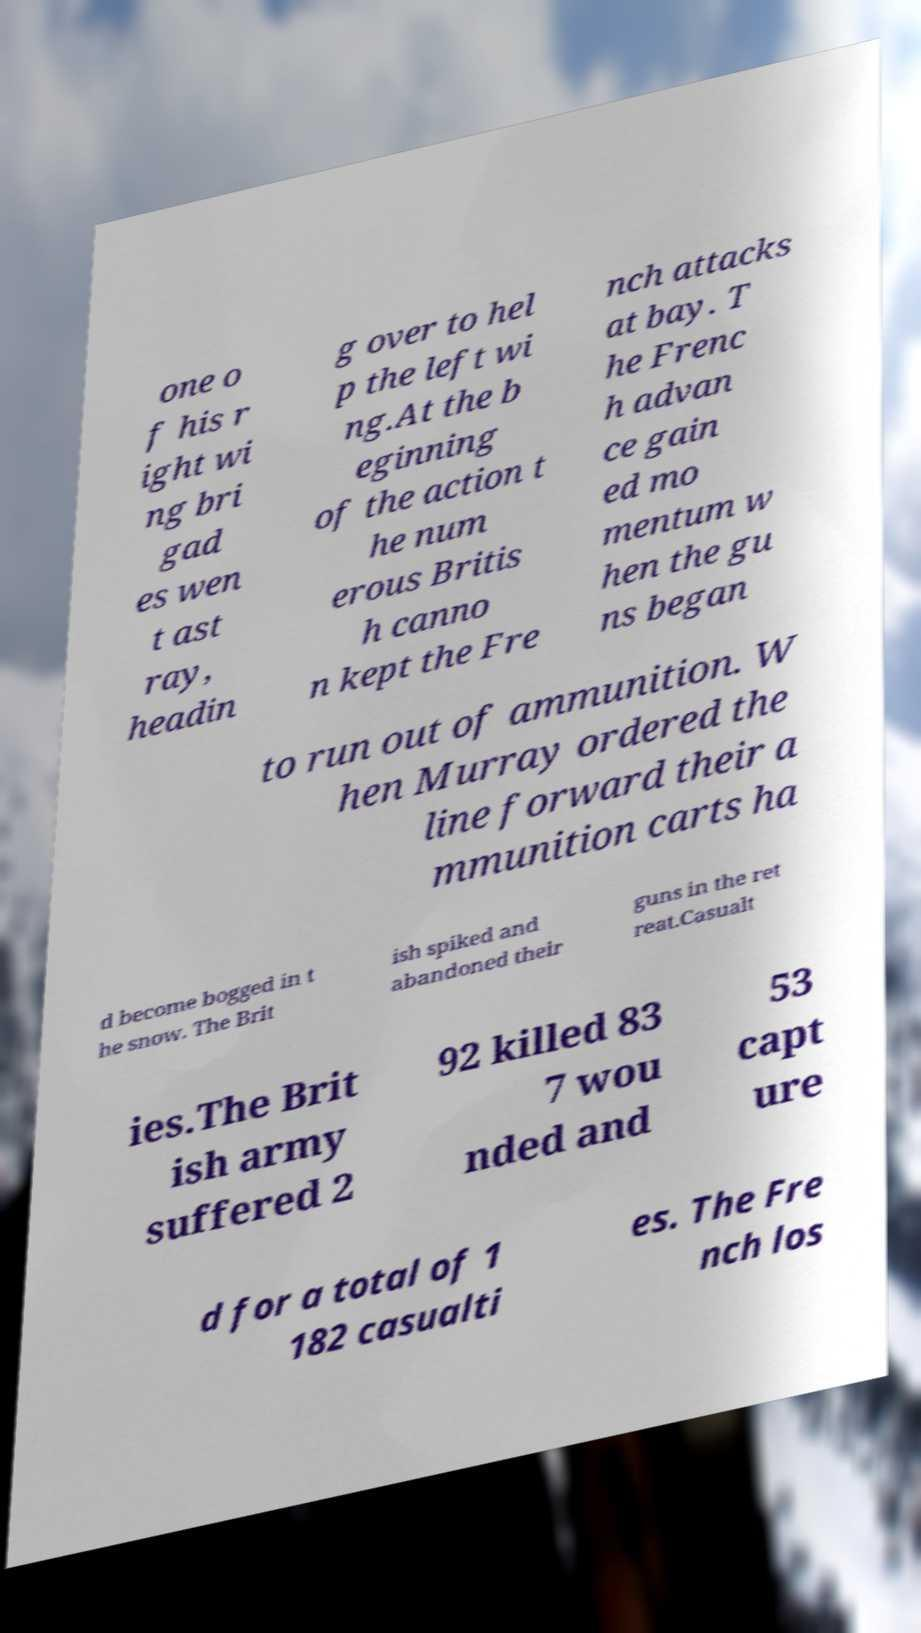Could you extract and type out the text from this image? one o f his r ight wi ng bri gad es wen t ast ray, headin g over to hel p the left wi ng.At the b eginning of the action t he num erous Britis h canno n kept the Fre nch attacks at bay. T he Frenc h advan ce gain ed mo mentum w hen the gu ns began to run out of ammunition. W hen Murray ordered the line forward their a mmunition carts ha d become bogged in t he snow. The Brit ish spiked and abandoned their guns in the ret reat.Casualt ies.The Brit ish army suffered 2 92 killed 83 7 wou nded and 53 capt ure d for a total of 1 182 casualti es. The Fre nch los 